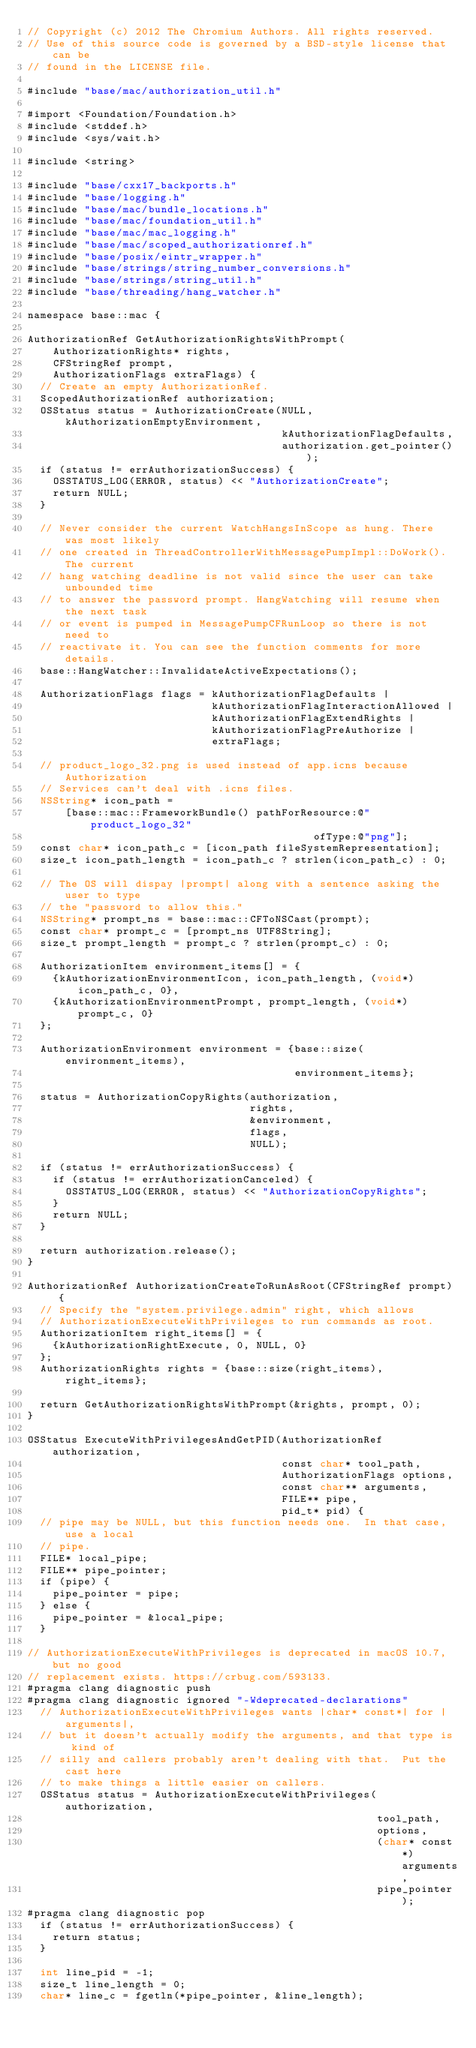<code> <loc_0><loc_0><loc_500><loc_500><_ObjectiveC_>// Copyright (c) 2012 The Chromium Authors. All rights reserved.
// Use of this source code is governed by a BSD-style license that can be
// found in the LICENSE file.

#include "base/mac/authorization_util.h"

#import <Foundation/Foundation.h>
#include <stddef.h>
#include <sys/wait.h>

#include <string>

#include "base/cxx17_backports.h"
#include "base/logging.h"
#include "base/mac/bundle_locations.h"
#include "base/mac/foundation_util.h"
#include "base/mac/mac_logging.h"
#include "base/mac/scoped_authorizationref.h"
#include "base/posix/eintr_wrapper.h"
#include "base/strings/string_number_conversions.h"
#include "base/strings/string_util.h"
#include "base/threading/hang_watcher.h"

namespace base::mac {

AuthorizationRef GetAuthorizationRightsWithPrompt(
    AuthorizationRights* rights,
    CFStringRef prompt,
    AuthorizationFlags extraFlags) {
  // Create an empty AuthorizationRef.
  ScopedAuthorizationRef authorization;
  OSStatus status = AuthorizationCreate(NULL, kAuthorizationEmptyEnvironment,
                                        kAuthorizationFlagDefaults,
                                        authorization.get_pointer());
  if (status != errAuthorizationSuccess) {
    OSSTATUS_LOG(ERROR, status) << "AuthorizationCreate";
    return NULL;
  }

  // Never consider the current WatchHangsInScope as hung. There was most likely
  // one created in ThreadControllerWithMessagePumpImpl::DoWork(). The current
  // hang watching deadline is not valid since the user can take unbounded time
  // to answer the password prompt. HangWatching will resume when the next task
  // or event is pumped in MessagePumpCFRunLoop so there is not need to
  // reactivate it. You can see the function comments for more details.
  base::HangWatcher::InvalidateActiveExpectations();

  AuthorizationFlags flags = kAuthorizationFlagDefaults |
                             kAuthorizationFlagInteractionAllowed |
                             kAuthorizationFlagExtendRights |
                             kAuthorizationFlagPreAuthorize |
                             extraFlags;

  // product_logo_32.png is used instead of app.icns because Authorization
  // Services can't deal with .icns files.
  NSString* icon_path =
      [base::mac::FrameworkBundle() pathForResource:@"product_logo_32"
                                             ofType:@"png"];
  const char* icon_path_c = [icon_path fileSystemRepresentation];
  size_t icon_path_length = icon_path_c ? strlen(icon_path_c) : 0;

  // The OS will dispay |prompt| along with a sentence asking the user to type
  // the "password to allow this."
  NSString* prompt_ns = base::mac::CFToNSCast(prompt);
  const char* prompt_c = [prompt_ns UTF8String];
  size_t prompt_length = prompt_c ? strlen(prompt_c) : 0;

  AuthorizationItem environment_items[] = {
    {kAuthorizationEnvironmentIcon, icon_path_length, (void*)icon_path_c, 0},
    {kAuthorizationEnvironmentPrompt, prompt_length, (void*)prompt_c, 0}
  };

  AuthorizationEnvironment environment = {base::size(environment_items),
                                          environment_items};

  status = AuthorizationCopyRights(authorization,
                                   rights,
                                   &environment,
                                   flags,
                                   NULL);

  if (status != errAuthorizationSuccess) {
    if (status != errAuthorizationCanceled) {
      OSSTATUS_LOG(ERROR, status) << "AuthorizationCopyRights";
    }
    return NULL;
  }

  return authorization.release();
}

AuthorizationRef AuthorizationCreateToRunAsRoot(CFStringRef prompt) {
  // Specify the "system.privilege.admin" right, which allows
  // AuthorizationExecuteWithPrivileges to run commands as root.
  AuthorizationItem right_items[] = {
    {kAuthorizationRightExecute, 0, NULL, 0}
  };
  AuthorizationRights rights = {base::size(right_items), right_items};

  return GetAuthorizationRightsWithPrompt(&rights, prompt, 0);
}

OSStatus ExecuteWithPrivilegesAndGetPID(AuthorizationRef authorization,
                                        const char* tool_path,
                                        AuthorizationFlags options,
                                        const char** arguments,
                                        FILE** pipe,
                                        pid_t* pid) {
  // pipe may be NULL, but this function needs one.  In that case, use a local
  // pipe.
  FILE* local_pipe;
  FILE** pipe_pointer;
  if (pipe) {
    pipe_pointer = pipe;
  } else {
    pipe_pointer = &local_pipe;
  }

// AuthorizationExecuteWithPrivileges is deprecated in macOS 10.7, but no good
// replacement exists. https://crbug.com/593133.
#pragma clang diagnostic push
#pragma clang diagnostic ignored "-Wdeprecated-declarations"
  // AuthorizationExecuteWithPrivileges wants |char* const*| for |arguments|,
  // but it doesn't actually modify the arguments, and that type is kind of
  // silly and callers probably aren't dealing with that.  Put the cast here
  // to make things a little easier on callers.
  OSStatus status = AuthorizationExecuteWithPrivileges(authorization,
                                                       tool_path,
                                                       options,
                                                       (char* const*)arguments,
                                                       pipe_pointer);
#pragma clang diagnostic pop
  if (status != errAuthorizationSuccess) {
    return status;
  }

  int line_pid = -1;
  size_t line_length = 0;
  char* line_c = fgetln(*pipe_pointer, &line_length);</code> 